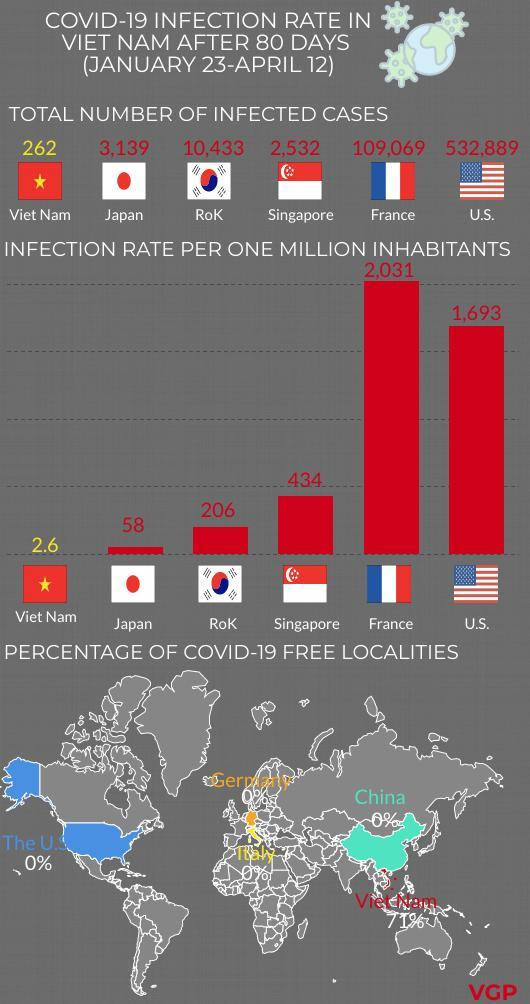How many countries' flags are shown?
Answer the question with a short phrase. 6 By what number is France ahead of Singapore in terms of infected cases? 1,06,537 Which country has the second lowest total infected cases? Japan Which countries have infection rate below 400? Viet Nam, Japan, RoK 